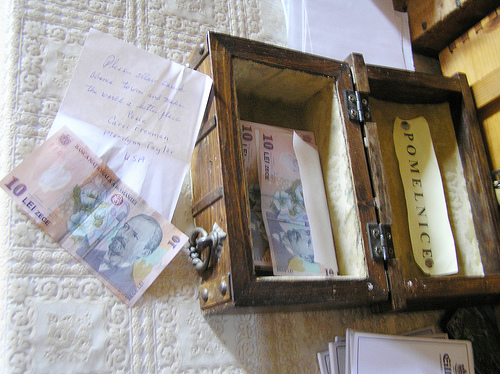<image>
Can you confirm if the note is in the box? No. The note is not contained within the box. These objects have a different spatial relationship. 